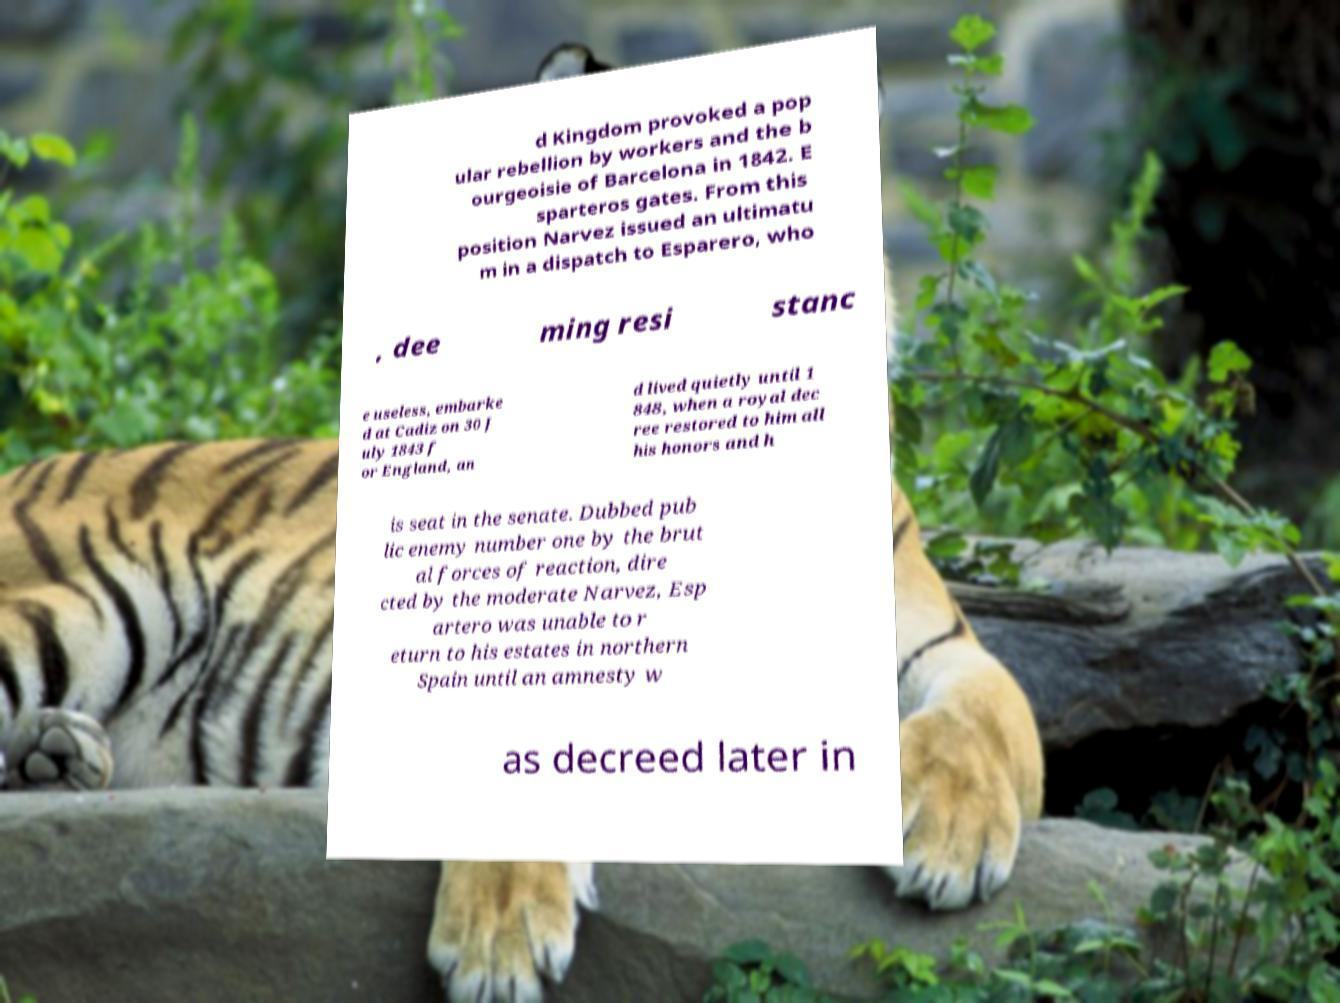What messages or text are displayed in this image? I need them in a readable, typed format. d Kingdom provoked a pop ular rebellion by workers and the b ourgeoisie of Barcelona in 1842. E sparteros gates. From this position Narvez issued an ultimatu m in a dispatch to Esparero, who , dee ming resi stanc e useless, embarke d at Cadiz on 30 J uly 1843 f or England, an d lived quietly until 1 848, when a royal dec ree restored to him all his honors and h is seat in the senate. Dubbed pub lic enemy number one by the brut al forces of reaction, dire cted by the moderate Narvez, Esp artero was unable to r eturn to his estates in northern Spain until an amnesty w as decreed later in 